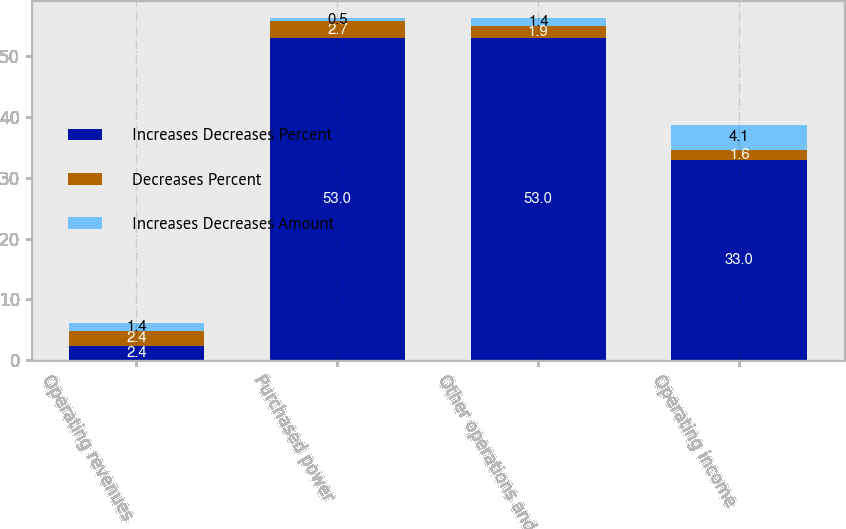Convert chart to OTSL. <chart><loc_0><loc_0><loc_500><loc_500><stacked_bar_chart><ecel><fcel>Operating revenues<fcel>Purchased power<fcel>Other operations and<fcel>Operating income<nl><fcel>Increases Decreases Percent<fcel>2.4<fcel>53<fcel>53<fcel>33<nl><fcel>Decreases Percent<fcel>2.4<fcel>2.7<fcel>1.9<fcel>1.6<nl><fcel>Increases Decreases Amount<fcel>1.4<fcel>0.5<fcel>1.4<fcel>4.1<nl></chart> 